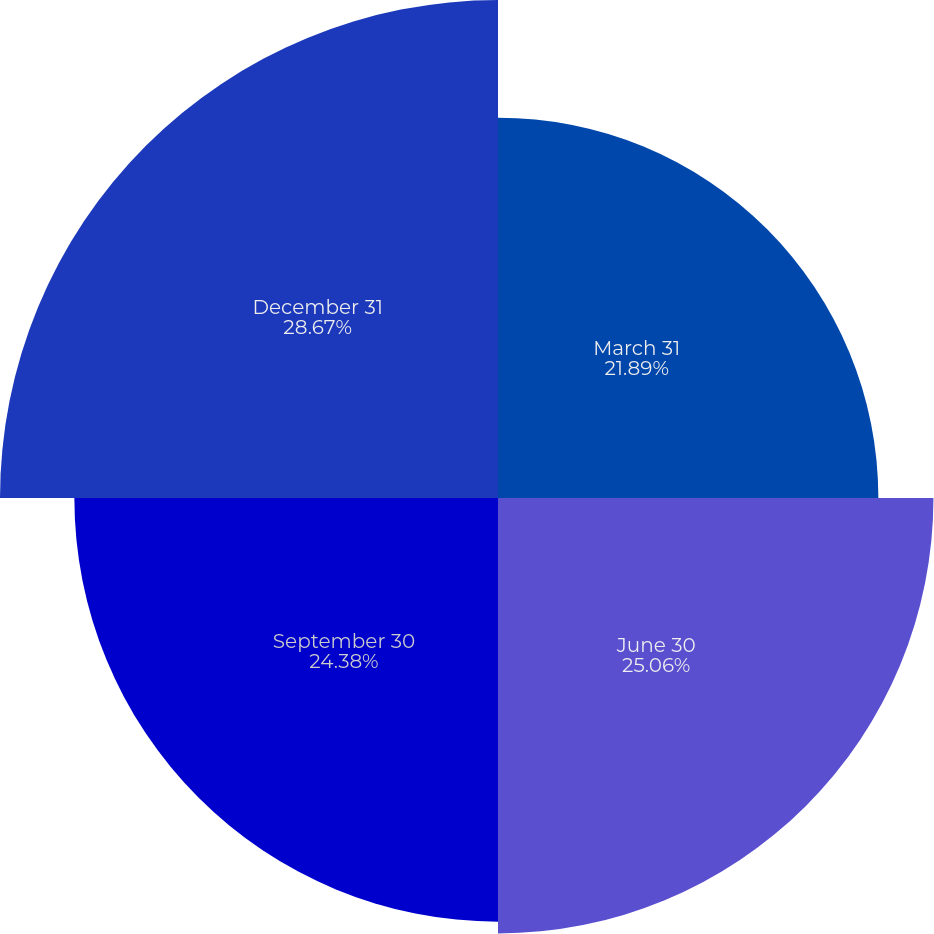Convert chart. <chart><loc_0><loc_0><loc_500><loc_500><pie_chart><fcel>March 31<fcel>June 30<fcel>September 30<fcel>December 31<nl><fcel>21.89%<fcel>25.06%<fcel>24.38%<fcel>28.66%<nl></chart> 